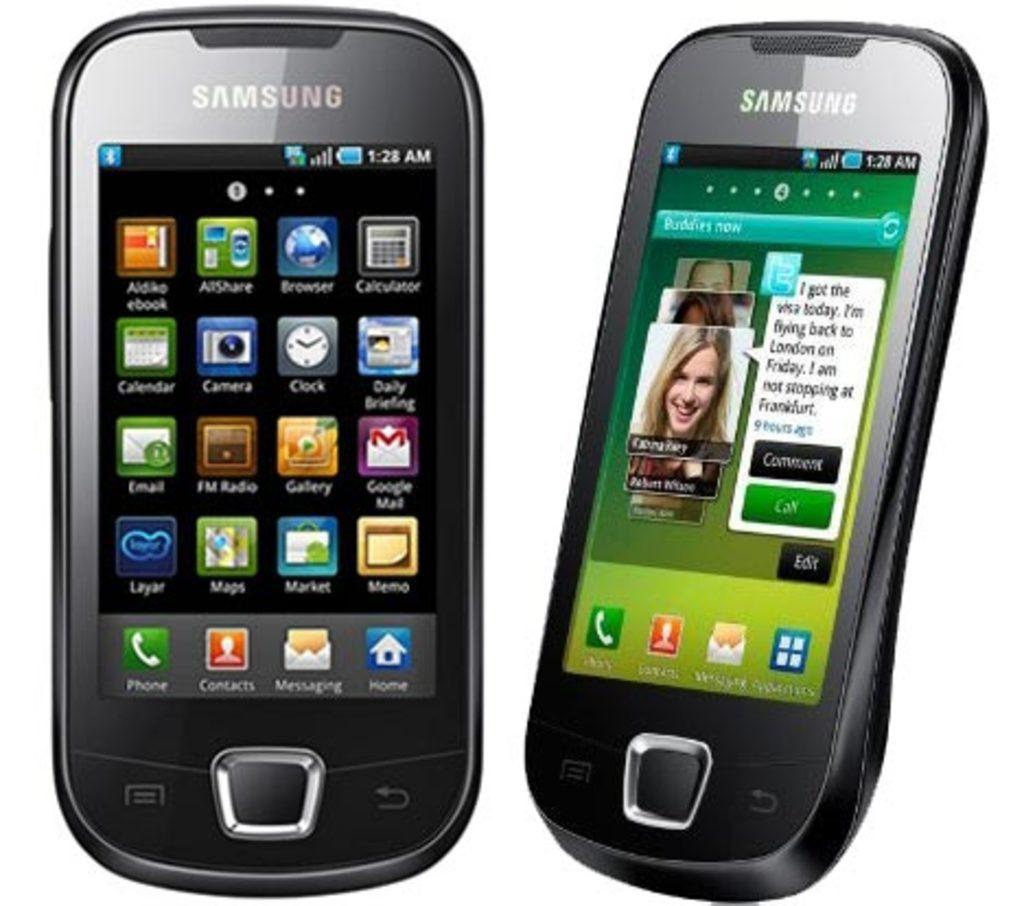<image>
Offer a succinct explanation of the picture presented. Two Samsung smart phones standing up by themselves. 